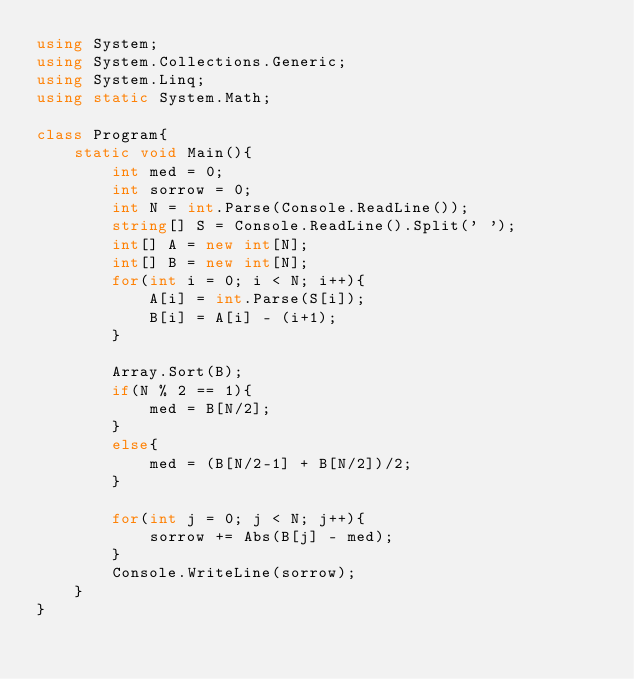Convert code to text. <code><loc_0><loc_0><loc_500><loc_500><_C#_>using System;
using System.Collections.Generic;
using System.Linq;
using static System.Math;

class Program{
    static void Main(){
        int med = 0;
        int sorrow = 0;
        int N = int.Parse(Console.ReadLine());
        string[] S = Console.ReadLine().Split(' ');
        int[] A = new int[N];
        int[] B = new int[N];
        for(int i = 0; i < N; i++){
            A[i] = int.Parse(S[i]);
            B[i] = A[i] - (i+1);
        }

        Array.Sort(B);
        if(N % 2 == 1){
            med = B[N/2];
        }
        else{
            med = (B[N/2-1] + B[N/2])/2;
        }

        for(int j = 0; j < N; j++){
            sorrow += Abs(B[j] - med);
        }
        Console.WriteLine(sorrow);
    }
}</code> 